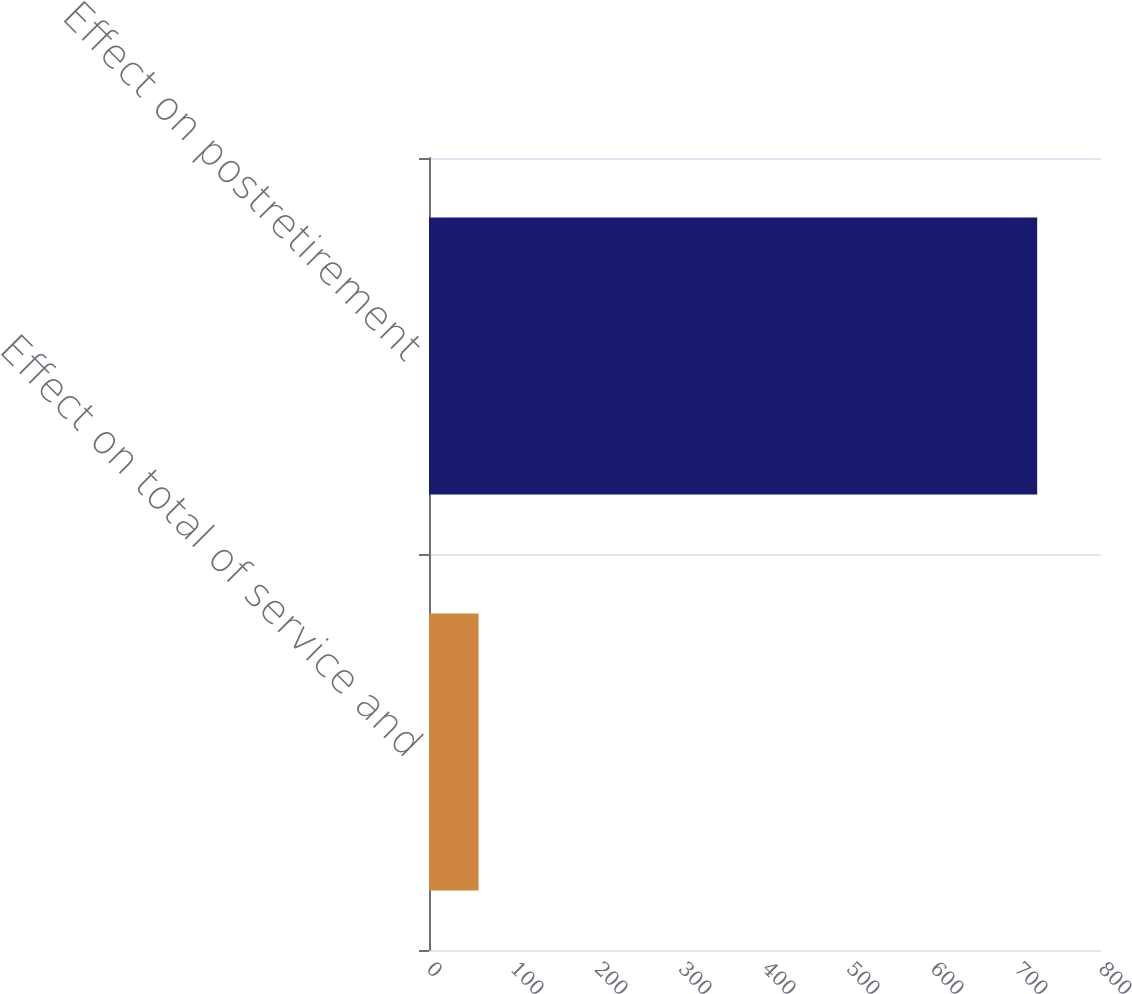Convert chart to OTSL. <chart><loc_0><loc_0><loc_500><loc_500><bar_chart><fcel>Effect on total of service and<fcel>Effect on postretirement<nl><fcel>59<fcel>724<nl></chart> 